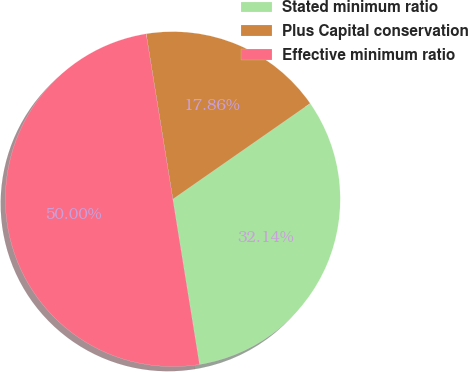Convert chart. <chart><loc_0><loc_0><loc_500><loc_500><pie_chart><fcel>Stated minimum ratio<fcel>Plus Capital conservation<fcel>Effective minimum ratio<nl><fcel>32.14%<fcel>17.86%<fcel>50.0%<nl></chart> 